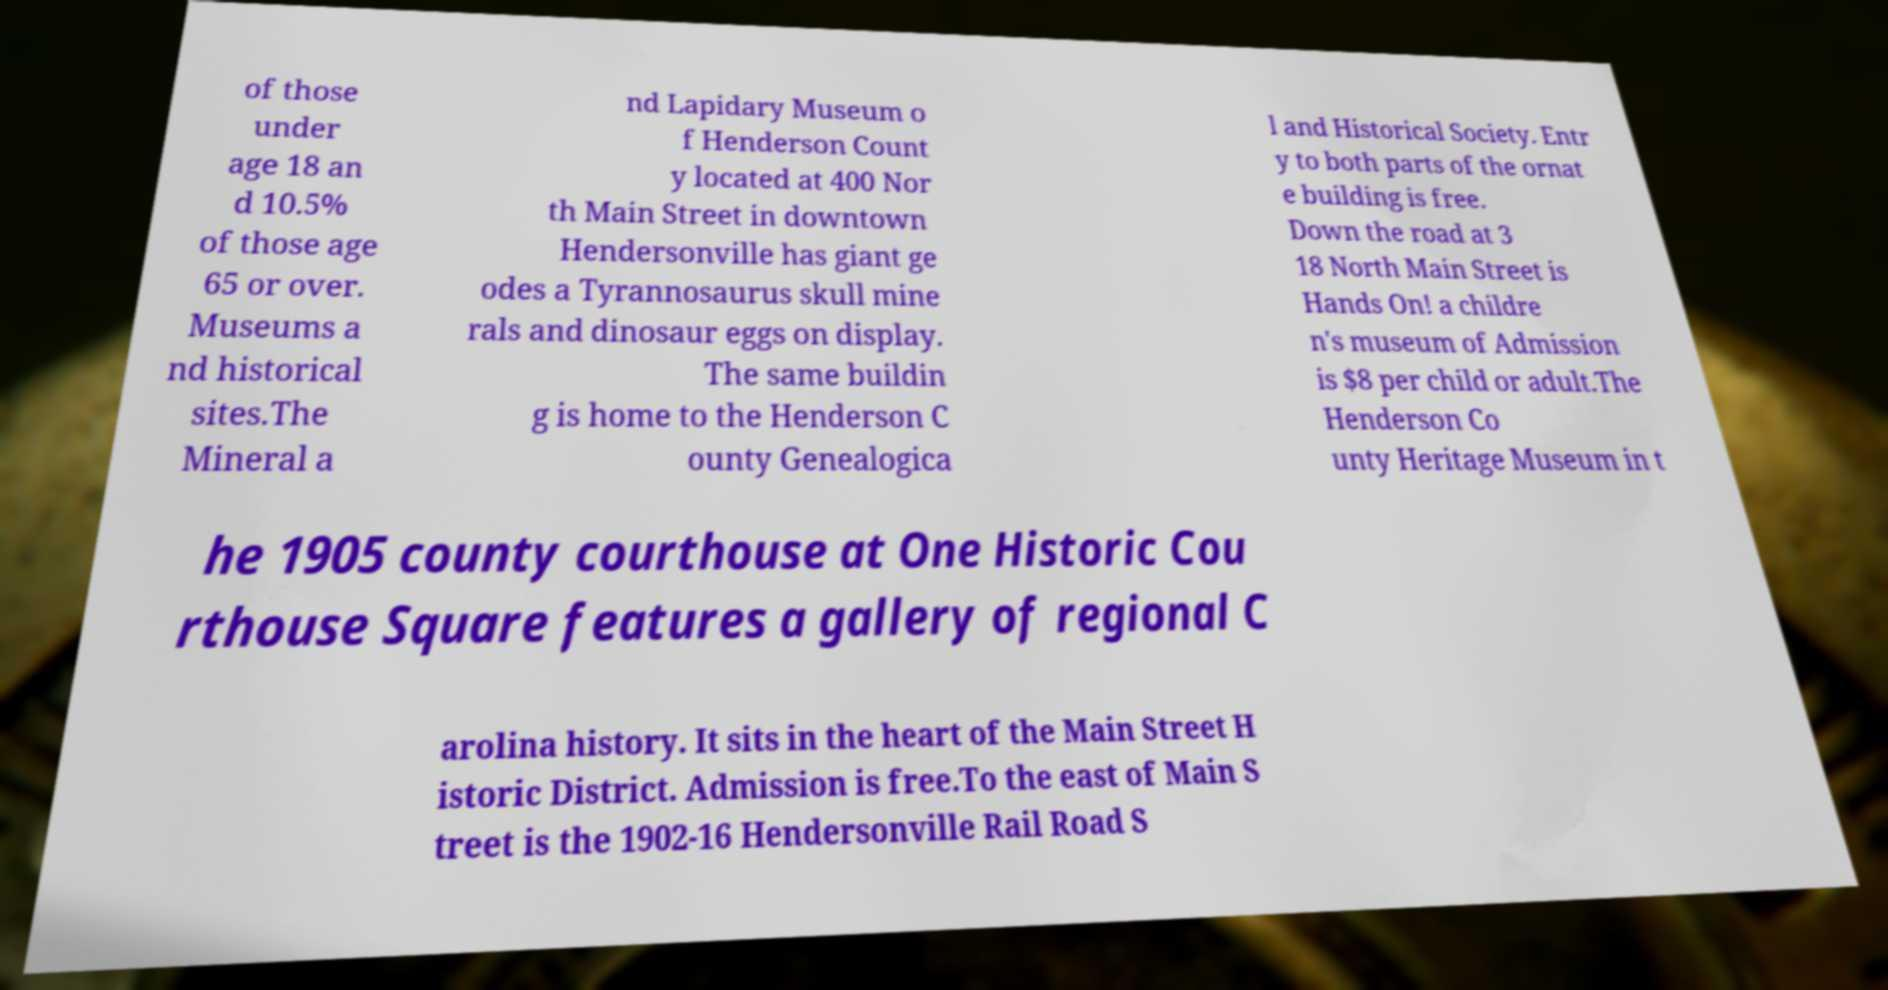Can you accurately transcribe the text from the provided image for me? of those under age 18 an d 10.5% of those age 65 or over. Museums a nd historical sites.The Mineral a nd Lapidary Museum o f Henderson Count y located at 400 Nor th Main Street in downtown Hendersonville has giant ge odes a Tyrannosaurus skull mine rals and dinosaur eggs on display. The same buildin g is home to the Henderson C ounty Genealogica l and Historical Society. Entr y to both parts of the ornat e building is free. Down the road at 3 18 North Main Street is Hands On! a childre n's museum of Admission is $8 per child or adult.The Henderson Co unty Heritage Museum in t he 1905 county courthouse at One Historic Cou rthouse Square features a gallery of regional C arolina history. It sits in the heart of the Main Street H istoric District. Admission is free.To the east of Main S treet is the 1902-16 Hendersonville Rail Road S 